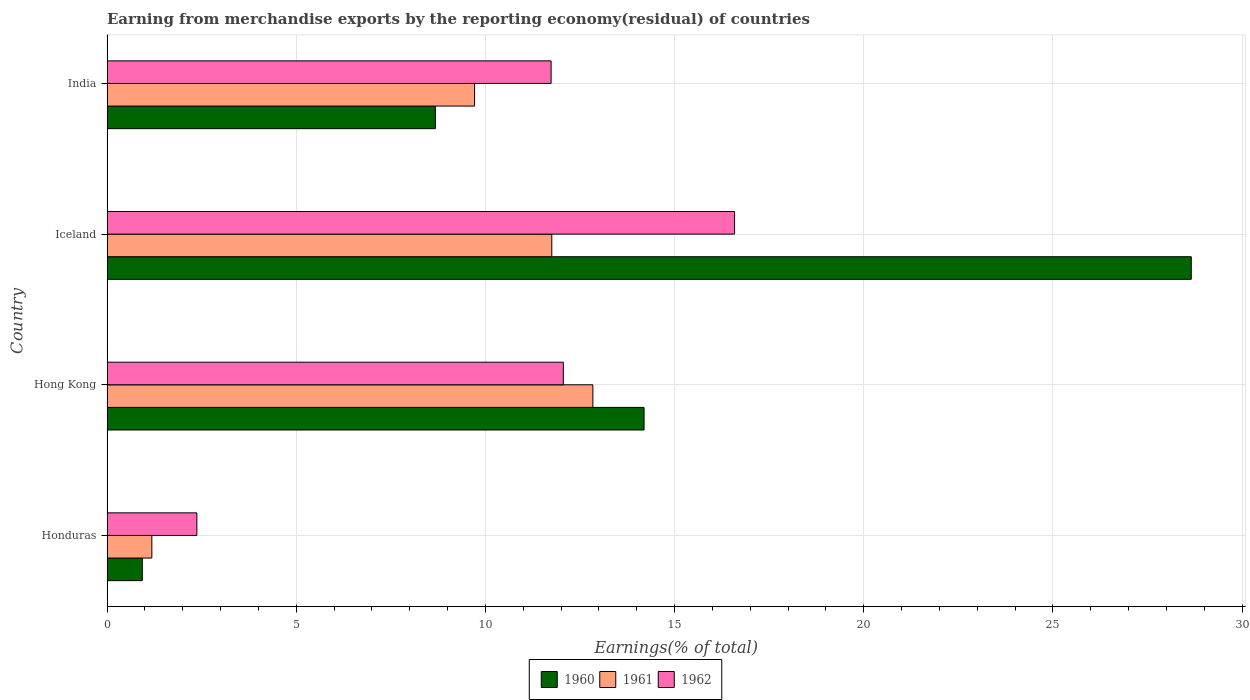Are the number of bars on each tick of the Y-axis equal?
Provide a succinct answer. Yes. How many bars are there on the 2nd tick from the top?
Ensure brevity in your answer.  3. What is the percentage of amount earned from merchandise exports in 1962 in Honduras?
Make the answer very short. 2.38. Across all countries, what is the maximum percentage of amount earned from merchandise exports in 1960?
Ensure brevity in your answer.  28.66. Across all countries, what is the minimum percentage of amount earned from merchandise exports in 1962?
Give a very brief answer. 2.38. In which country was the percentage of amount earned from merchandise exports in 1961 minimum?
Keep it short and to the point. Honduras. What is the total percentage of amount earned from merchandise exports in 1962 in the graph?
Your response must be concise. 42.76. What is the difference between the percentage of amount earned from merchandise exports in 1961 in Hong Kong and that in India?
Ensure brevity in your answer.  3.13. What is the difference between the percentage of amount earned from merchandise exports in 1962 in Honduras and the percentage of amount earned from merchandise exports in 1961 in Iceland?
Your answer should be very brief. -9.38. What is the average percentage of amount earned from merchandise exports in 1961 per country?
Provide a short and direct response. 8.87. What is the difference between the percentage of amount earned from merchandise exports in 1960 and percentage of amount earned from merchandise exports in 1962 in Hong Kong?
Offer a terse response. 2.13. What is the ratio of the percentage of amount earned from merchandise exports in 1960 in Honduras to that in India?
Provide a succinct answer. 0.11. Is the difference between the percentage of amount earned from merchandise exports in 1960 in Hong Kong and Iceland greater than the difference between the percentage of amount earned from merchandise exports in 1962 in Hong Kong and Iceland?
Make the answer very short. No. What is the difference between the highest and the second highest percentage of amount earned from merchandise exports in 1962?
Your answer should be compact. 4.53. What is the difference between the highest and the lowest percentage of amount earned from merchandise exports in 1960?
Provide a succinct answer. 27.73. In how many countries, is the percentage of amount earned from merchandise exports in 1961 greater than the average percentage of amount earned from merchandise exports in 1961 taken over all countries?
Make the answer very short. 3. What does the 3rd bar from the top in India represents?
Offer a very short reply. 1960. What does the 2nd bar from the bottom in Hong Kong represents?
Your answer should be compact. 1961. How many bars are there?
Keep it short and to the point. 12. Are all the bars in the graph horizontal?
Offer a terse response. Yes. How many countries are there in the graph?
Your answer should be compact. 4. What is the difference between two consecutive major ticks on the X-axis?
Provide a short and direct response. 5. Does the graph contain grids?
Give a very brief answer. Yes. How many legend labels are there?
Give a very brief answer. 3. How are the legend labels stacked?
Offer a very short reply. Horizontal. What is the title of the graph?
Your response must be concise. Earning from merchandise exports by the reporting economy(residual) of countries. Does "2004" appear as one of the legend labels in the graph?
Your answer should be very brief. No. What is the label or title of the X-axis?
Your response must be concise. Earnings(% of total). What is the label or title of the Y-axis?
Make the answer very short. Country. What is the Earnings(% of total) of 1960 in Honduras?
Offer a terse response. 0.93. What is the Earnings(% of total) of 1961 in Honduras?
Provide a succinct answer. 1.19. What is the Earnings(% of total) of 1962 in Honduras?
Your answer should be very brief. 2.38. What is the Earnings(% of total) in 1960 in Hong Kong?
Offer a terse response. 14.2. What is the Earnings(% of total) in 1961 in Hong Kong?
Offer a very short reply. 12.84. What is the Earnings(% of total) of 1962 in Hong Kong?
Give a very brief answer. 12.06. What is the Earnings(% of total) in 1960 in Iceland?
Ensure brevity in your answer.  28.66. What is the Earnings(% of total) in 1961 in Iceland?
Keep it short and to the point. 11.76. What is the Earnings(% of total) in 1962 in Iceland?
Your answer should be compact. 16.59. What is the Earnings(% of total) of 1960 in India?
Provide a short and direct response. 8.68. What is the Earnings(% of total) in 1961 in India?
Offer a terse response. 9.71. What is the Earnings(% of total) in 1962 in India?
Your answer should be compact. 11.74. Across all countries, what is the maximum Earnings(% of total) of 1960?
Offer a terse response. 28.66. Across all countries, what is the maximum Earnings(% of total) of 1961?
Offer a very short reply. 12.84. Across all countries, what is the maximum Earnings(% of total) of 1962?
Make the answer very short. 16.59. Across all countries, what is the minimum Earnings(% of total) in 1960?
Offer a terse response. 0.93. Across all countries, what is the minimum Earnings(% of total) of 1961?
Provide a short and direct response. 1.19. Across all countries, what is the minimum Earnings(% of total) of 1962?
Provide a short and direct response. 2.38. What is the total Earnings(% of total) in 1960 in the graph?
Provide a short and direct response. 52.47. What is the total Earnings(% of total) in 1961 in the graph?
Ensure brevity in your answer.  35.5. What is the total Earnings(% of total) in 1962 in the graph?
Provide a succinct answer. 42.76. What is the difference between the Earnings(% of total) in 1960 in Honduras and that in Hong Kong?
Keep it short and to the point. -13.26. What is the difference between the Earnings(% of total) in 1961 in Honduras and that in Hong Kong?
Your answer should be compact. -11.66. What is the difference between the Earnings(% of total) in 1962 in Honduras and that in Hong Kong?
Offer a very short reply. -9.69. What is the difference between the Earnings(% of total) of 1960 in Honduras and that in Iceland?
Your response must be concise. -27.73. What is the difference between the Earnings(% of total) in 1961 in Honduras and that in Iceland?
Your answer should be very brief. -10.57. What is the difference between the Earnings(% of total) of 1962 in Honduras and that in Iceland?
Your answer should be compact. -14.21. What is the difference between the Earnings(% of total) in 1960 in Honduras and that in India?
Your answer should be compact. -7.75. What is the difference between the Earnings(% of total) in 1961 in Honduras and that in India?
Provide a short and direct response. -8.53. What is the difference between the Earnings(% of total) in 1962 in Honduras and that in India?
Your answer should be very brief. -9.36. What is the difference between the Earnings(% of total) of 1960 in Hong Kong and that in Iceland?
Make the answer very short. -14.46. What is the difference between the Earnings(% of total) of 1961 in Hong Kong and that in Iceland?
Give a very brief answer. 1.09. What is the difference between the Earnings(% of total) of 1962 in Hong Kong and that in Iceland?
Provide a short and direct response. -4.53. What is the difference between the Earnings(% of total) of 1960 in Hong Kong and that in India?
Your answer should be compact. 5.52. What is the difference between the Earnings(% of total) in 1961 in Hong Kong and that in India?
Keep it short and to the point. 3.13. What is the difference between the Earnings(% of total) of 1962 in Hong Kong and that in India?
Give a very brief answer. 0.32. What is the difference between the Earnings(% of total) in 1960 in Iceland and that in India?
Your answer should be very brief. 19.98. What is the difference between the Earnings(% of total) of 1961 in Iceland and that in India?
Make the answer very short. 2.04. What is the difference between the Earnings(% of total) in 1962 in Iceland and that in India?
Ensure brevity in your answer.  4.85. What is the difference between the Earnings(% of total) of 1960 in Honduras and the Earnings(% of total) of 1961 in Hong Kong?
Offer a terse response. -11.91. What is the difference between the Earnings(% of total) of 1960 in Honduras and the Earnings(% of total) of 1962 in Hong Kong?
Make the answer very short. -11.13. What is the difference between the Earnings(% of total) of 1961 in Honduras and the Earnings(% of total) of 1962 in Hong Kong?
Give a very brief answer. -10.88. What is the difference between the Earnings(% of total) in 1960 in Honduras and the Earnings(% of total) in 1961 in Iceland?
Provide a succinct answer. -10.82. What is the difference between the Earnings(% of total) of 1960 in Honduras and the Earnings(% of total) of 1962 in Iceland?
Give a very brief answer. -15.65. What is the difference between the Earnings(% of total) of 1961 in Honduras and the Earnings(% of total) of 1962 in Iceland?
Offer a terse response. -15.4. What is the difference between the Earnings(% of total) of 1960 in Honduras and the Earnings(% of total) of 1961 in India?
Your answer should be compact. -8.78. What is the difference between the Earnings(% of total) in 1960 in Honduras and the Earnings(% of total) in 1962 in India?
Keep it short and to the point. -10.8. What is the difference between the Earnings(% of total) of 1961 in Honduras and the Earnings(% of total) of 1962 in India?
Give a very brief answer. -10.55. What is the difference between the Earnings(% of total) of 1960 in Hong Kong and the Earnings(% of total) of 1961 in Iceland?
Make the answer very short. 2.44. What is the difference between the Earnings(% of total) of 1960 in Hong Kong and the Earnings(% of total) of 1962 in Iceland?
Provide a succinct answer. -2.39. What is the difference between the Earnings(% of total) in 1961 in Hong Kong and the Earnings(% of total) in 1962 in Iceland?
Your answer should be very brief. -3.75. What is the difference between the Earnings(% of total) of 1960 in Hong Kong and the Earnings(% of total) of 1961 in India?
Your answer should be very brief. 4.48. What is the difference between the Earnings(% of total) in 1960 in Hong Kong and the Earnings(% of total) in 1962 in India?
Provide a succinct answer. 2.46. What is the difference between the Earnings(% of total) in 1961 in Hong Kong and the Earnings(% of total) in 1962 in India?
Ensure brevity in your answer.  1.1. What is the difference between the Earnings(% of total) in 1960 in Iceland and the Earnings(% of total) in 1961 in India?
Offer a terse response. 18.94. What is the difference between the Earnings(% of total) in 1960 in Iceland and the Earnings(% of total) in 1962 in India?
Offer a terse response. 16.92. What is the difference between the Earnings(% of total) in 1961 in Iceland and the Earnings(% of total) in 1962 in India?
Your answer should be compact. 0.02. What is the average Earnings(% of total) in 1960 per country?
Provide a short and direct response. 13.12. What is the average Earnings(% of total) in 1961 per country?
Your answer should be compact. 8.87. What is the average Earnings(% of total) of 1962 per country?
Your response must be concise. 10.69. What is the difference between the Earnings(% of total) of 1960 and Earnings(% of total) of 1961 in Honduras?
Your response must be concise. -0.25. What is the difference between the Earnings(% of total) in 1960 and Earnings(% of total) in 1962 in Honduras?
Give a very brief answer. -1.44. What is the difference between the Earnings(% of total) in 1961 and Earnings(% of total) in 1962 in Honduras?
Provide a short and direct response. -1.19. What is the difference between the Earnings(% of total) of 1960 and Earnings(% of total) of 1961 in Hong Kong?
Your answer should be very brief. 1.35. What is the difference between the Earnings(% of total) of 1960 and Earnings(% of total) of 1962 in Hong Kong?
Your answer should be very brief. 2.13. What is the difference between the Earnings(% of total) in 1961 and Earnings(% of total) in 1962 in Hong Kong?
Your answer should be compact. 0.78. What is the difference between the Earnings(% of total) in 1960 and Earnings(% of total) in 1961 in Iceland?
Ensure brevity in your answer.  16.9. What is the difference between the Earnings(% of total) of 1960 and Earnings(% of total) of 1962 in Iceland?
Give a very brief answer. 12.07. What is the difference between the Earnings(% of total) of 1961 and Earnings(% of total) of 1962 in Iceland?
Give a very brief answer. -4.83. What is the difference between the Earnings(% of total) in 1960 and Earnings(% of total) in 1961 in India?
Ensure brevity in your answer.  -1.04. What is the difference between the Earnings(% of total) of 1960 and Earnings(% of total) of 1962 in India?
Give a very brief answer. -3.06. What is the difference between the Earnings(% of total) in 1961 and Earnings(% of total) in 1962 in India?
Your response must be concise. -2.02. What is the ratio of the Earnings(% of total) in 1960 in Honduras to that in Hong Kong?
Provide a short and direct response. 0.07. What is the ratio of the Earnings(% of total) in 1961 in Honduras to that in Hong Kong?
Keep it short and to the point. 0.09. What is the ratio of the Earnings(% of total) in 1962 in Honduras to that in Hong Kong?
Your response must be concise. 0.2. What is the ratio of the Earnings(% of total) of 1960 in Honduras to that in Iceland?
Offer a very short reply. 0.03. What is the ratio of the Earnings(% of total) in 1961 in Honduras to that in Iceland?
Provide a short and direct response. 0.1. What is the ratio of the Earnings(% of total) in 1962 in Honduras to that in Iceland?
Ensure brevity in your answer.  0.14. What is the ratio of the Earnings(% of total) of 1960 in Honduras to that in India?
Your answer should be compact. 0.11. What is the ratio of the Earnings(% of total) of 1961 in Honduras to that in India?
Offer a very short reply. 0.12. What is the ratio of the Earnings(% of total) of 1962 in Honduras to that in India?
Provide a succinct answer. 0.2. What is the ratio of the Earnings(% of total) in 1960 in Hong Kong to that in Iceland?
Your response must be concise. 0.5. What is the ratio of the Earnings(% of total) in 1961 in Hong Kong to that in Iceland?
Keep it short and to the point. 1.09. What is the ratio of the Earnings(% of total) of 1962 in Hong Kong to that in Iceland?
Your response must be concise. 0.73. What is the ratio of the Earnings(% of total) of 1960 in Hong Kong to that in India?
Offer a terse response. 1.64. What is the ratio of the Earnings(% of total) in 1961 in Hong Kong to that in India?
Ensure brevity in your answer.  1.32. What is the ratio of the Earnings(% of total) of 1962 in Hong Kong to that in India?
Provide a succinct answer. 1.03. What is the ratio of the Earnings(% of total) in 1960 in Iceland to that in India?
Make the answer very short. 3.3. What is the ratio of the Earnings(% of total) in 1961 in Iceland to that in India?
Make the answer very short. 1.21. What is the ratio of the Earnings(% of total) in 1962 in Iceland to that in India?
Your answer should be compact. 1.41. What is the difference between the highest and the second highest Earnings(% of total) of 1960?
Offer a terse response. 14.46. What is the difference between the highest and the second highest Earnings(% of total) of 1961?
Make the answer very short. 1.09. What is the difference between the highest and the second highest Earnings(% of total) of 1962?
Offer a terse response. 4.53. What is the difference between the highest and the lowest Earnings(% of total) in 1960?
Provide a short and direct response. 27.73. What is the difference between the highest and the lowest Earnings(% of total) of 1961?
Ensure brevity in your answer.  11.66. What is the difference between the highest and the lowest Earnings(% of total) of 1962?
Your response must be concise. 14.21. 